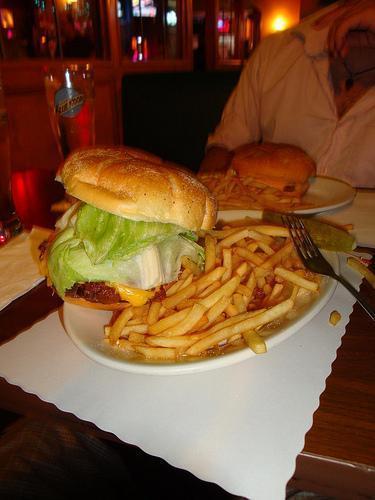How many sandwiches can you see?
Give a very brief answer. 2. How many cups can be seen?
Give a very brief answer. 2. 